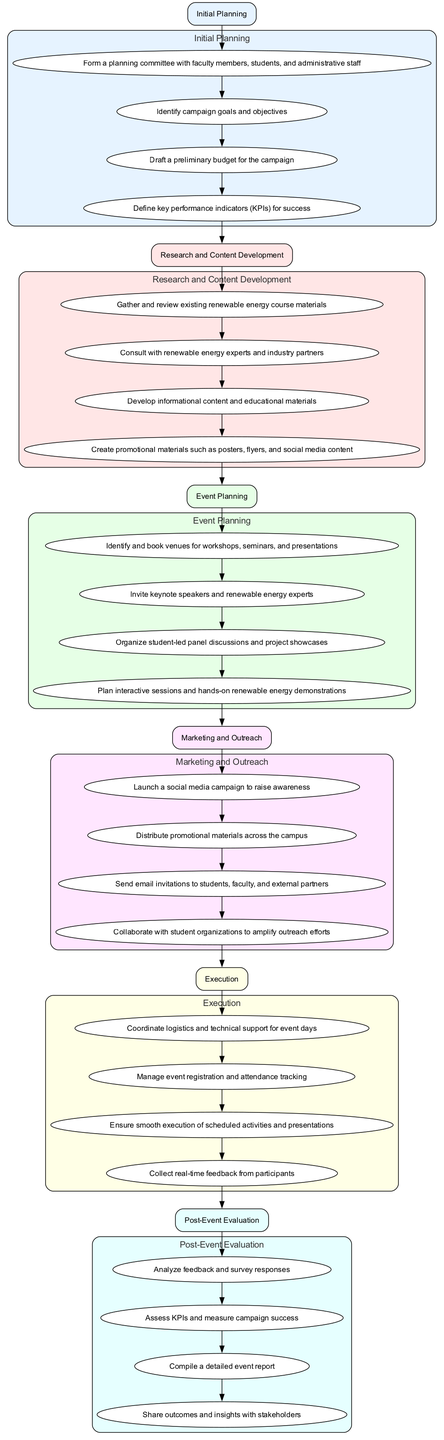What is the first step in organizing the campaign? The first step listed in the diagram is "Initial Planning." This is represented as the top node of the flowchart, indicating it is the starting point of the campaign organization process.
Answer: Initial Planning How many actions are listed under the "Post-Event Evaluation" step? In the diagram, the "Post-Event Evaluation" step has four associated actions. I can count each action connected to this step in the flowchart.
Answer: 4 What is the last action in the "Marketing and Outreach" step? The last action under "Marketing and Outreach" in the flowchart is "Collaborate with student organizations to amplify outreach efforts." This is identified as the final action connected to that particular step.
Answer: Collaborate with student organizations to amplify outreach efforts What is the relationship between the "Event Planning" step and its actions? The "Event Planning" step is linked to four actions, each indicating planned activities associated with organizing an event. The flowchart shows a direct connection from the "Event Planning" step to its first action, and then sequentially to each subsequent action, illustrating their relationship.
Answer: Sequential connection Which step comes after "Research and Content Development"? Following the "Research and Content Development" step in the diagram is the "Event Planning" step. This can be determined by examining the flow from one step to the next in the order they are arranged.
Answer: Event Planning How many total steps are there in the campaign organization process? The diagram contains a total of six steps listed, each represented as a distinct node in the flowchart detailing the campaign organization process.
Answer: 6 What is the main purpose of the "Initial Planning" step? The "Initial Planning" step's main purpose is to establish foundational aspects such as forming a planning committee, identifying goals, and drafting a budget. This can be inferred by the actions listed under this step in the flowchart.
Answer: Establish foundational aspects What connects the "Execution" step to its actions? The "Execution" step connects to its actions through a direct sequence where each action follows the previous one, indicating a structured approach to executing the event. This step is depicted at the lower part of the diagram leading directly into the specific actions.
Answer: Direct sequence 